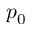<formula> <loc_0><loc_0><loc_500><loc_500>p _ { 0 }</formula> 